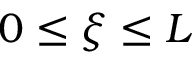<formula> <loc_0><loc_0><loc_500><loc_500>0 \leq \xi \leq L</formula> 